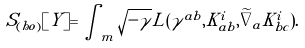Convert formula to latex. <formula><loc_0><loc_0><loc_500><loc_500>S _ { ( h o ) } [ Y ] = \int _ { m } \sqrt { - \gamma } L ( \gamma ^ { a b } , K _ { a b } ^ { i } , \widetilde { \nabla } _ { a } K _ { b c } ^ { i } ) .</formula> 